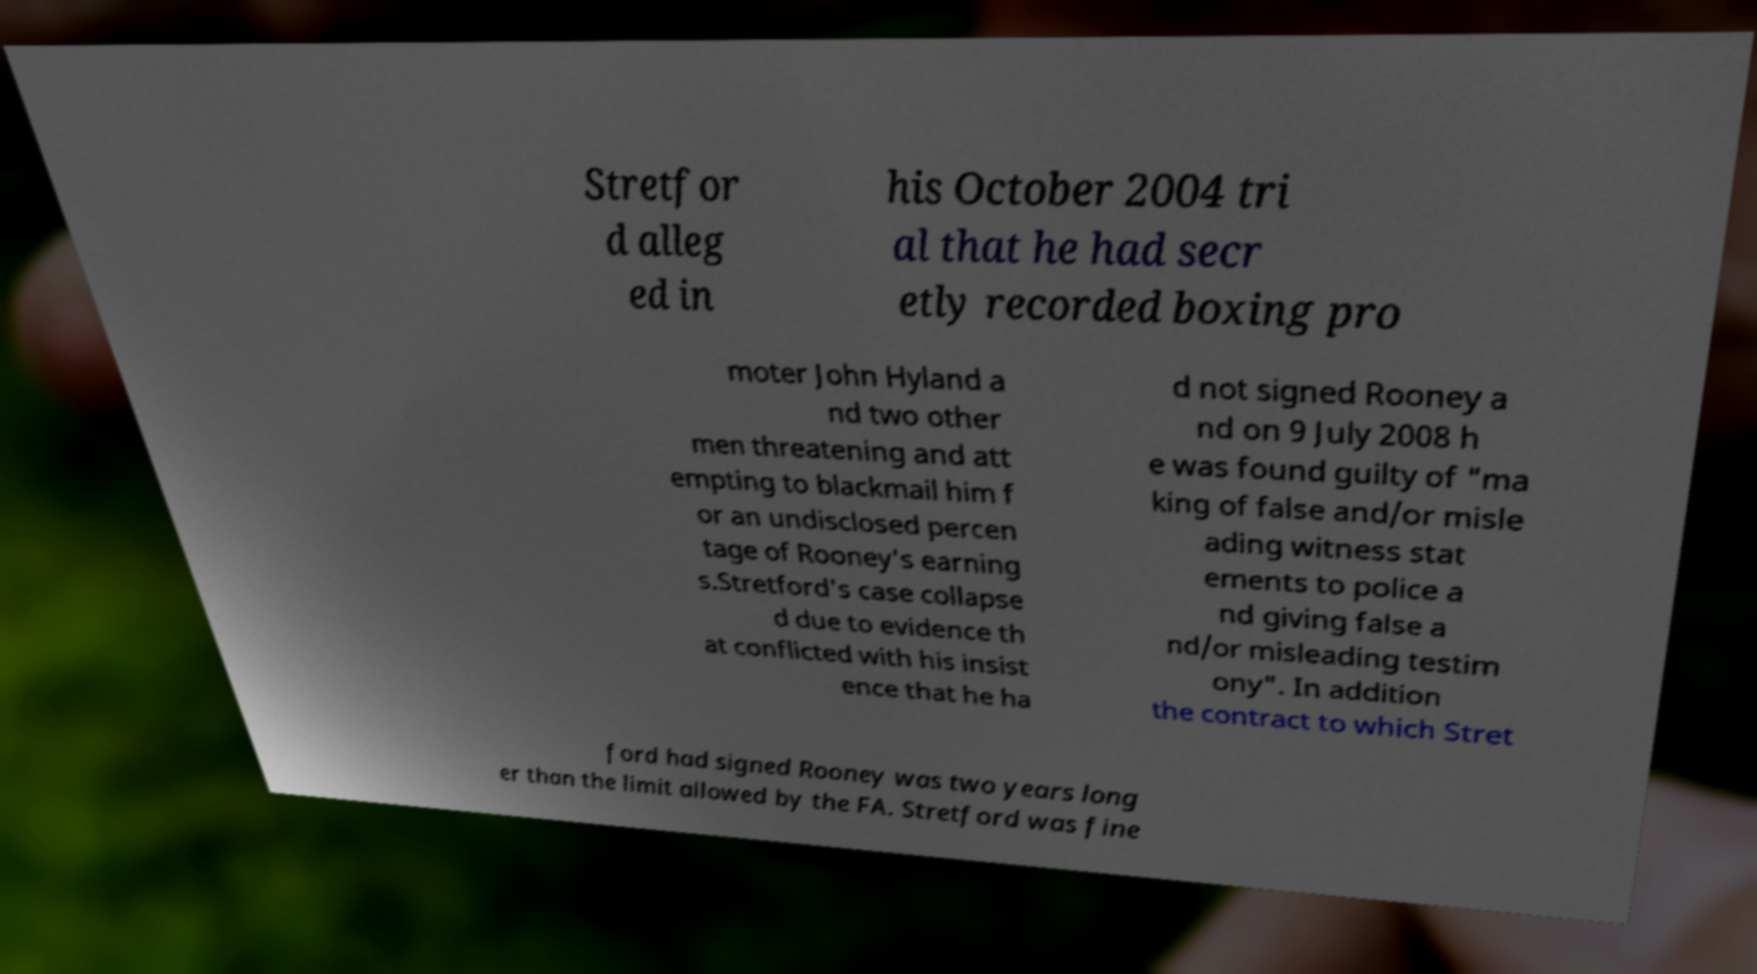There's text embedded in this image that I need extracted. Can you transcribe it verbatim? Stretfor d alleg ed in his October 2004 tri al that he had secr etly recorded boxing pro moter John Hyland a nd two other men threatening and att empting to blackmail him f or an undisclosed percen tage of Rooney's earning s.Stretford's case collapse d due to evidence th at conflicted with his insist ence that he ha d not signed Rooney a nd on 9 July 2008 h e was found guilty of "ma king of false and/or misle ading witness stat ements to police a nd giving false a nd/or misleading testim ony". In addition the contract to which Stret ford had signed Rooney was two years long er than the limit allowed by the FA. Stretford was fine 